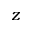<formula> <loc_0><loc_0><loc_500><loc_500>z</formula> 